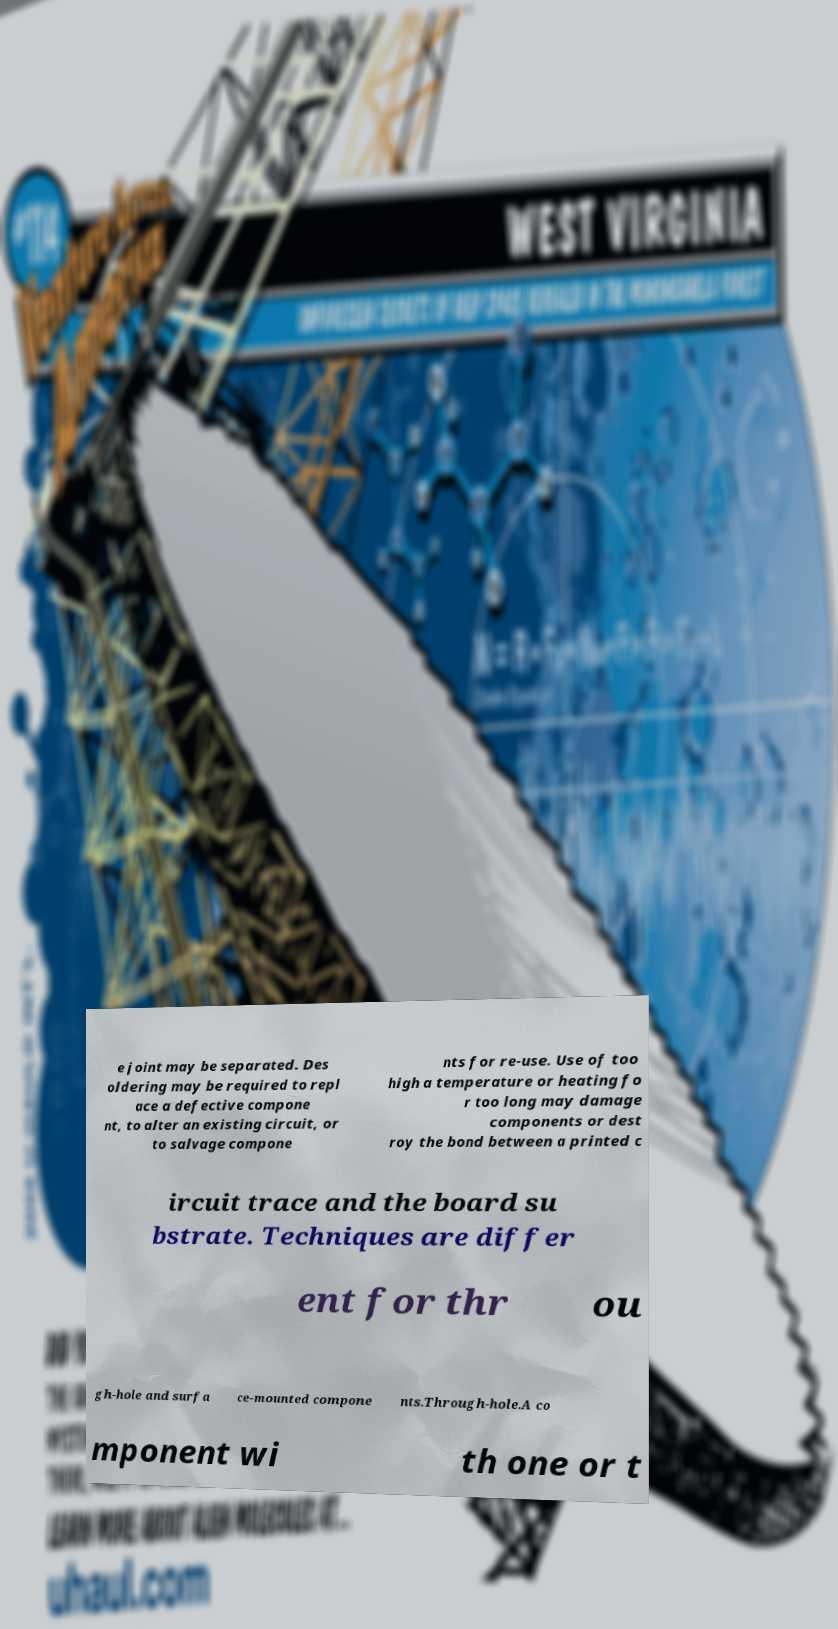What messages or text are displayed in this image? I need them in a readable, typed format. e joint may be separated. Des oldering may be required to repl ace a defective compone nt, to alter an existing circuit, or to salvage compone nts for re-use. Use of too high a temperature or heating fo r too long may damage components or dest roy the bond between a printed c ircuit trace and the board su bstrate. Techniques are differ ent for thr ou gh-hole and surfa ce-mounted compone nts.Through-hole.A co mponent wi th one or t 